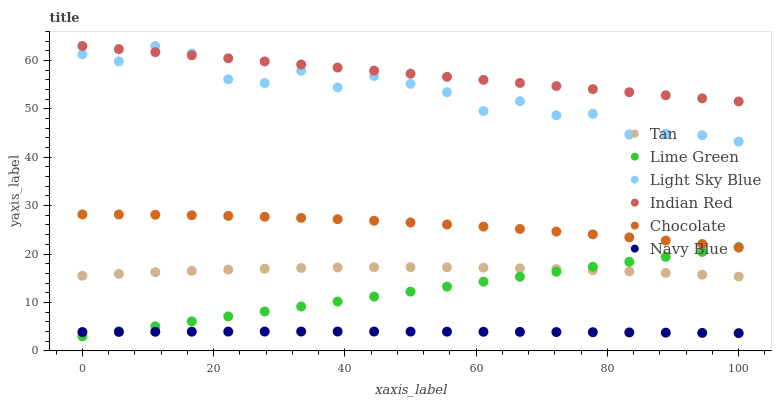Does Navy Blue have the minimum area under the curve?
Answer yes or no. Yes. Does Indian Red have the maximum area under the curve?
Answer yes or no. Yes. Does Chocolate have the minimum area under the curve?
Answer yes or no. No. Does Chocolate have the maximum area under the curve?
Answer yes or no. No. Is Lime Green the smoothest?
Answer yes or no. Yes. Is Light Sky Blue the roughest?
Answer yes or no. Yes. Is Chocolate the smoothest?
Answer yes or no. No. Is Chocolate the roughest?
Answer yes or no. No. Does Lime Green have the lowest value?
Answer yes or no. Yes. Does Chocolate have the lowest value?
Answer yes or no. No. Does Indian Red have the highest value?
Answer yes or no. Yes. Does Chocolate have the highest value?
Answer yes or no. No. Is Lime Green less than Indian Red?
Answer yes or no. Yes. Is Light Sky Blue greater than Lime Green?
Answer yes or no. Yes. Does Lime Green intersect Chocolate?
Answer yes or no. Yes. Is Lime Green less than Chocolate?
Answer yes or no. No. Is Lime Green greater than Chocolate?
Answer yes or no. No. Does Lime Green intersect Indian Red?
Answer yes or no. No. 